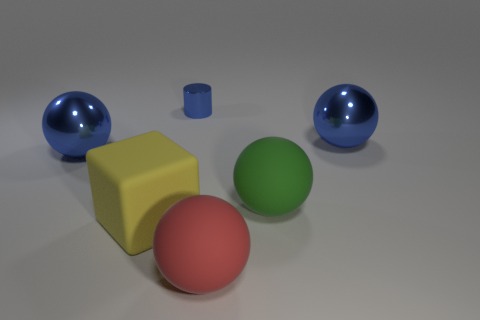Subtract all gray balls. Subtract all cyan cubes. How many balls are left? 4 Add 2 gray spheres. How many objects exist? 8 Subtract all cylinders. How many objects are left? 5 Subtract 0 cyan balls. How many objects are left? 6 Subtract all large red matte objects. Subtract all red spheres. How many objects are left? 4 Add 3 big matte objects. How many big matte objects are left? 6 Add 3 big blue shiny spheres. How many big blue shiny spheres exist? 5 